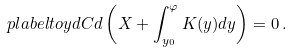<formula> <loc_0><loc_0><loc_500><loc_500>\ p l a b e l { t o y d C } d \left ( X + \int _ { y _ { 0 } } ^ { \varphi } K ( y ) d y \right ) = 0 \, .</formula> 